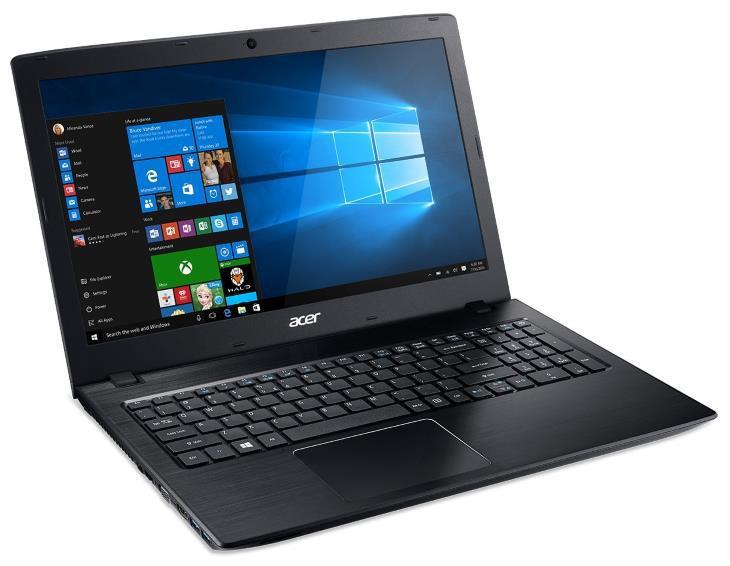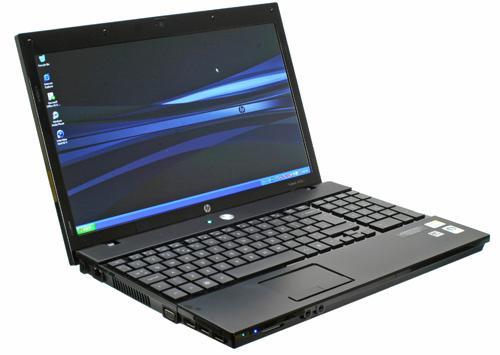The first image is the image on the left, the second image is the image on the right. Evaluate the accuracy of this statement regarding the images: "The left image contains one leftward-facing open laptop with a mostly black screen, and the right image contains one leftward-facing laptop with a mostly blue screen.". Is it true? Answer yes or no. No. The first image is the image on the left, the second image is the image on the right. Evaluate the accuracy of this statement regarding the images: "In at least one image there is an open laptop with a blue background, thats bottom is silver and frame around the screen is black.". Is it true? Answer yes or no. No. 